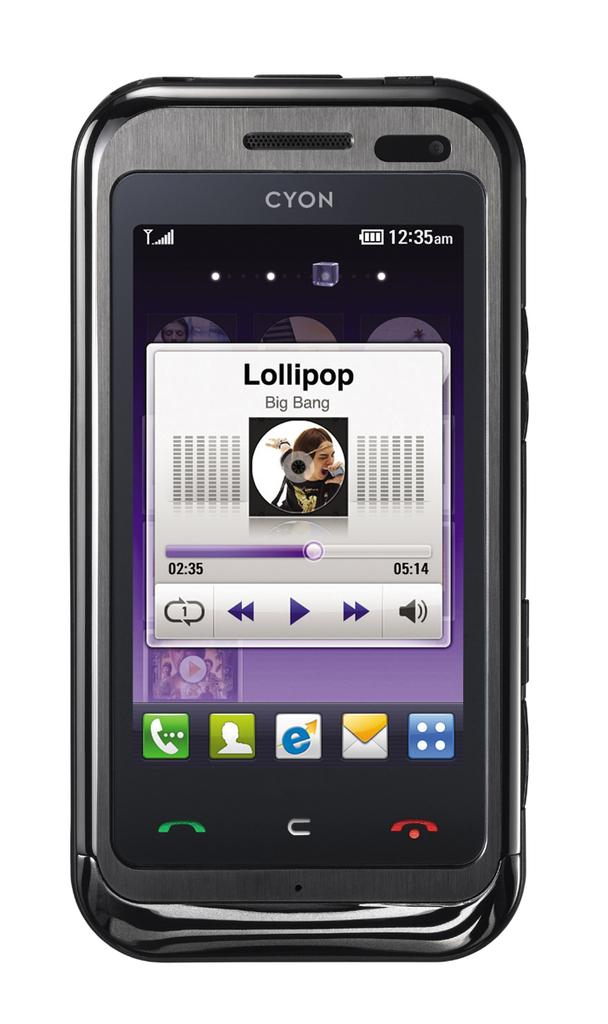<image>
Create a compact narrative representing the image presented. A CYON phone that is currently playing Lollipop. 